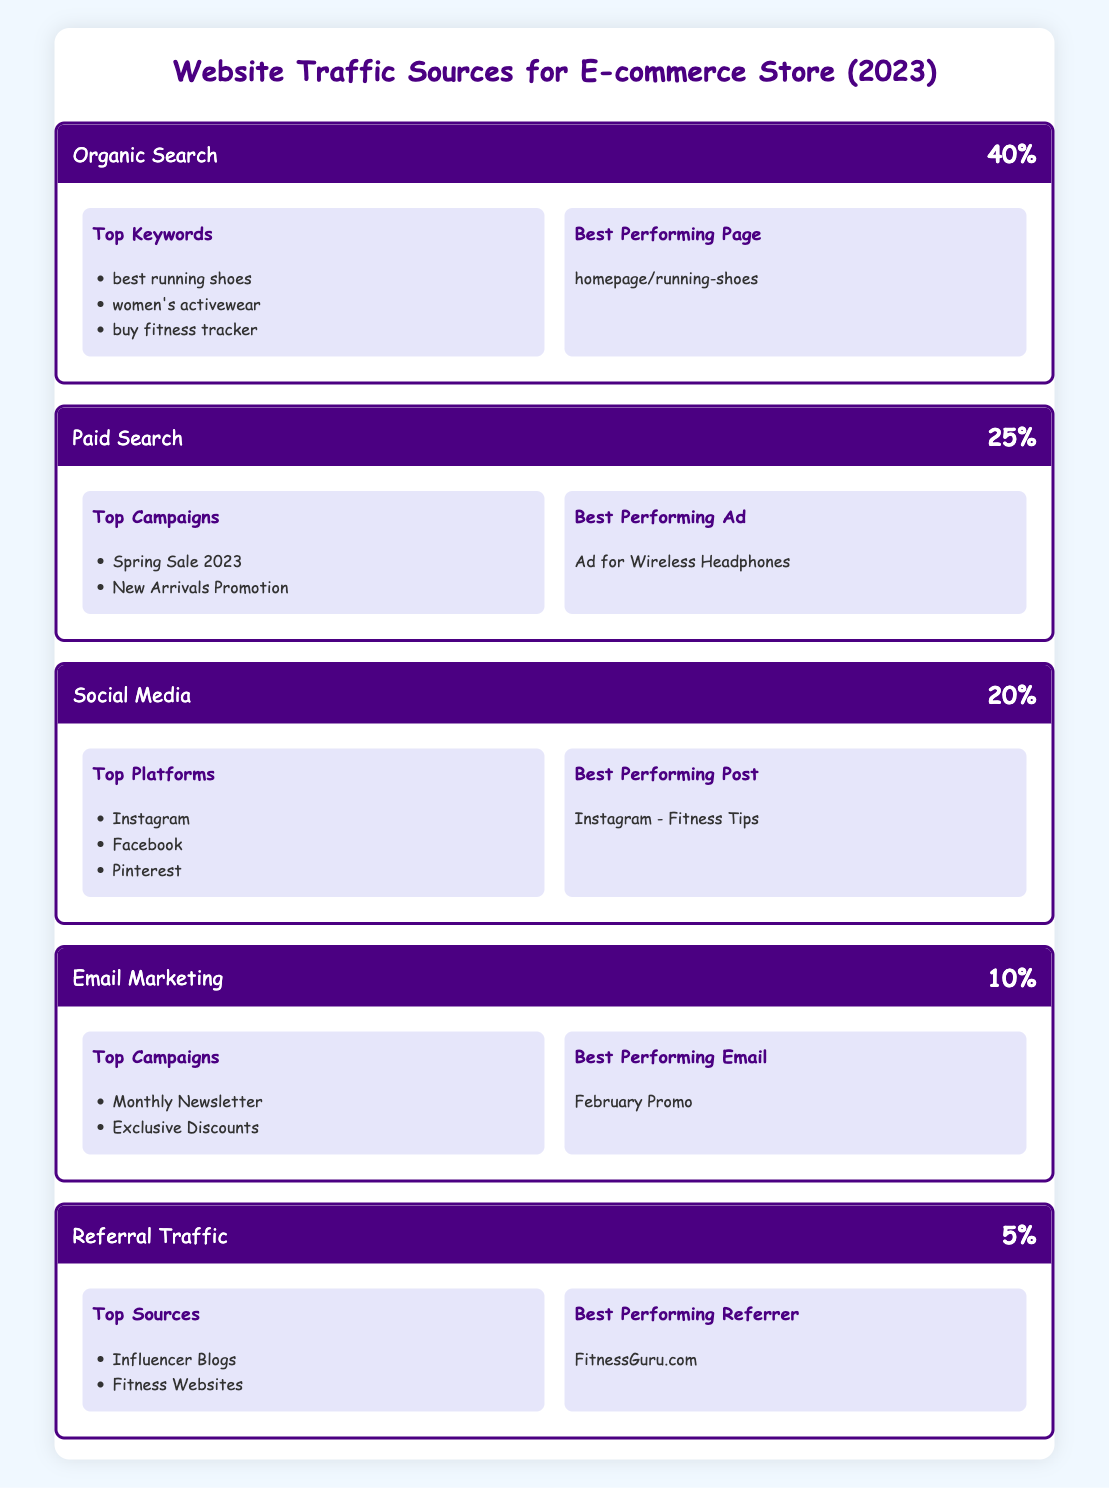What is the traffic percentage from Organic Search? Organic Search has a traffic percentage of 40%, which is stated directly in the table.
Answer: 40% What is the best performing page for Organic Search? The table indicates that the best performing page for Organic Search is the homepage/running-shoes.
Answer: homepage/running-shoes Which traffic source has the highest percentage? By comparing the traffic percentages in the table, Organic Search at 40% is the highest among all sources.
Answer: Organic Search How many traffic sources listed have a traffic percentage of 10% or lower? The sources with traffic percentages of 10% or lower are Email Marketing (10%) and Referral Traffic (5%). There are 2 sources.
Answer: 2 Is the best performing ad in Paid Search related to fitness products? The best performing ad is "Ad for Wireless Headphones," which is not specifically related to fitness products, as it refers to headphones instead of fitness items directly.
Answer: No If we assume the total traffic is 1000 visitors, how many visitors came from Paid Search? To find this, we calculate 25% of 1000. This is 1000 * 0.25 = 250 visitors from Paid Search.
Answer: 250 What are the top platforms for Social Media traffic? According to the table, the top platforms for Social Media traffic are Instagram, Facebook, and Pinterest as listed directly under that traffic source.
Answer: Instagram, Facebook, Pinterest Is the traffic percentage for Referral Traffic greater than that for Email Marketing? Referral Traffic at 5% is less than Email Marketing, which has a traffic percentage of 10%, so the statement is false.
Answer: No What is the total traffic percentage for all sources listed? By adding the traffic percentages together: 40% + 25% + 20% + 10% + 5% = 100%. Therefore, the total traffic percentage is 100%.
Answer: 100% 